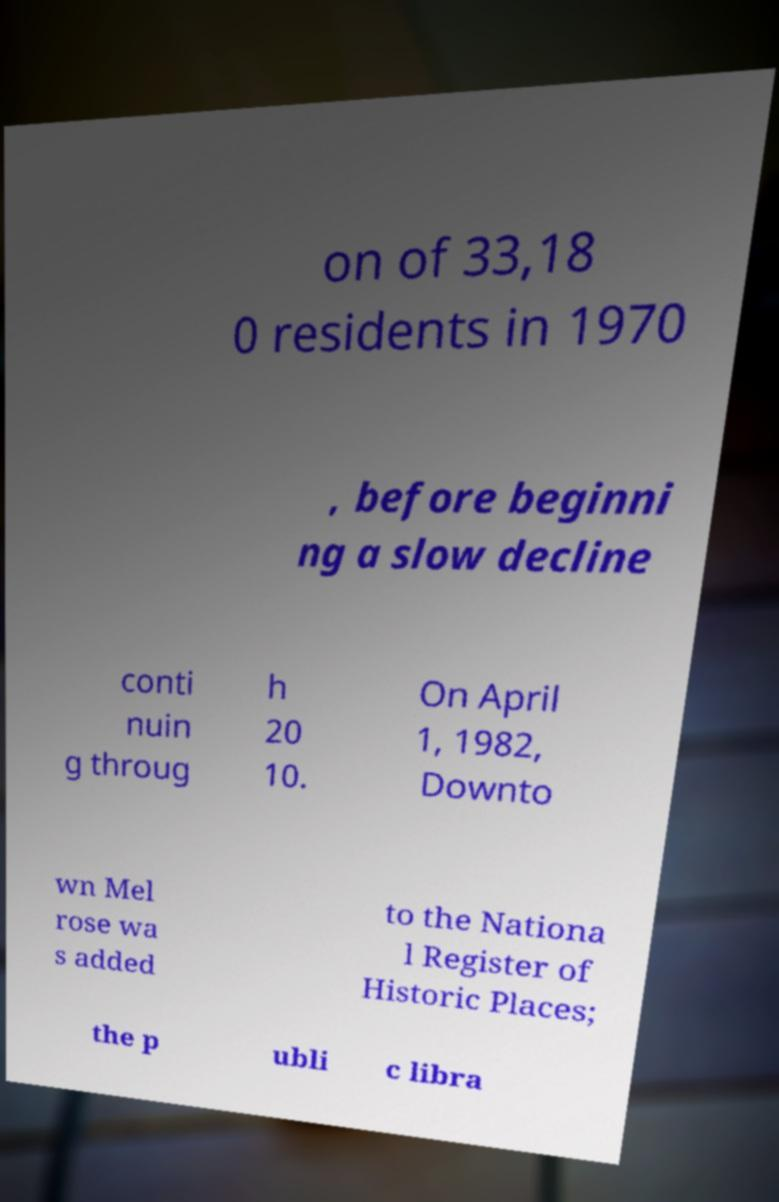Could you extract and type out the text from this image? on of 33,18 0 residents in 1970 , before beginni ng a slow decline conti nuin g throug h 20 10. On April 1, 1982, Downto wn Mel rose wa s added to the Nationa l Register of Historic Places; the p ubli c libra 